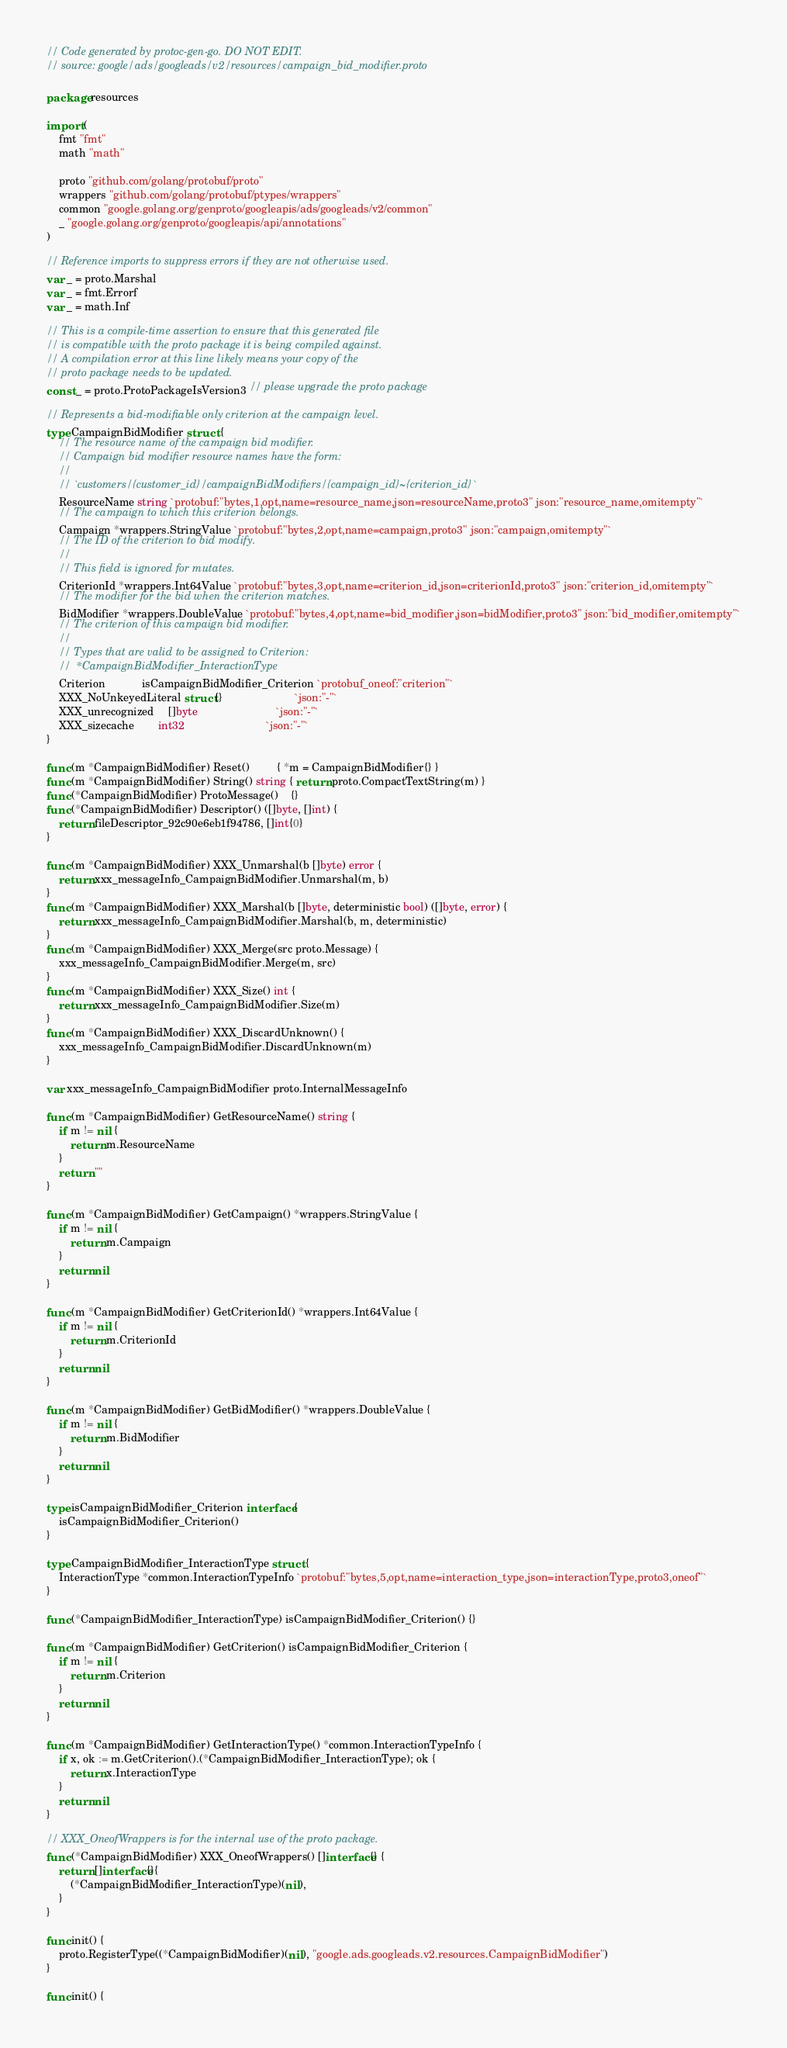<code> <loc_0><loc_0><loc_500><loc_500><_Go_>// Code generated by protoc-gen-go. DO NOT EDIT.
// source: google/ads/googleads/v2/resources/campaign_bid_modifier.proto

package resources

import (
	fmt "fmt"
	math "math"

	proto "github.com/golang/protobuf/proto"
	wrappers "github.com/golang/protobuf/ptypes/wrappers"
	common "google.golang.org/genproto/googleapis/ads/googleads/v2/common"
	_ "google.golang.org/genproto/googleapis/api/annotations"
)

// Reference imports to suppress errors if they are not otherwise used.
var _ = proto.Marshal
var _ = fmt.Errorf
var _ = math.Inf

// This is a compile-time assertion to ensure that this generated file
// is compatible with the proto package it is being compiled against.
// A compilation error at this line likely means your copy of the
// proto package needs to be updated.
const _ = proto.ProtoPackageIsVersion3 // please upgrade the proto package

// Represents a bid-modifiable only criterion at the campaign level.
type CampaignBidModifier struct {
	// The resource name of the campaign bid modifier.
	// Campaign bid modifier resource names have the form:
	//
	// `customers/{customer_id}/campaignBidModifiers/{campaign_id}~{criterion_id}`
	ResourceName string `protobuf:"bytes,1,opt,name=resource_name,json=resourceName,proto3" json:"resource_name,omitempty"`
	// The campaign to which this criterion belongs.
	Campaign *wrappers.StringValue `protobuf:"bytes,2,opt,name=campaign,proto3" json:"campaign,omitempty"`
	// The ID of the criterion to bid modify.
	//
	// This field is ignored for mutates.
	CriterionId *wrappers.Int64Value `protobuf:"bytes,3,opt,name=criterion_id,json=criterionId,proto3" json:"criterion_id,omitempty"`
	// The modifier for the bid when the criterion matches.
	BidModifier *wrappers.DoubleValue `protobuf:"bytes,4,opt,name=bid_modifier,json=bidModifier,proto3" json:"bid_modifier,omitempty"`
	// The criterion of this campaign bid modifier.
	//
	// Types that are valid to be assigned to Criterion:
	//	*CampaignBidModifier_InteractionType
	Criterion            isCampaignBidModifier_Criterion `protobuf_oneof:"criterion"`
	XXX_NoUnkeyedLiteral struct{}                        `json:"-"`
	XXX_unrecognized     []byte                          `json:"-"`
	XXX_sizecache        int32                           `json:"-"`
}

func (m *CampaignBidModifier) Reset()         { *m = CampaignBidModifier{} }
func (m *CampaignBidModifier) String() string { return proto.CompactTextString(m) }
func (*CampaignBidModifier) ProtoMessage()    {}
func (*CampaignBidModifier) Descriptor() ([]byte, []int) {
	return fileDescriptor_92c90e6eb1f94786, []int{0}
}

func (m *CampaignBidModifier) XXX_Unmarshal(b []byte) error {
	return xxx_messageInfo_CampaignBidModifier.Unmarshal(m, b)
}
func (m *CampaignBidModifier) XXX_Marshal(b []byte, deterministic bool) ([]byte, error) {
	return xxx_messageInfo_CampaignBidModifier.Marshal(b, m, deterministic)
}
func (m *CampaignBidModifier) XXX_Merge(src proto.Message) {
	xxx_messageInfo_CampaignBidModifier.Merge(m, src)
}
func (m *CampaignBidModifier) XXX_Size() int {
	return xxx_messageInfo_CampaignBidModifier.Size(m)
}
func (m *CampaignBidModifier) XXX_DiscardUnknown() {
	xxx_messageInfo_CampaignBidModifier.DiscardUnknown(m)
}

var xxx_messageInfo_CampaignBidModifier proto.InternalMessageInfo

func (m *CampaignBidModifier) GetResourceName() string {
	if m != nil {
		return m.ResourceName
	}
	return ""
}

func (m *CampaignBidModifier) GetCampaign() *wrappers.StringValue {
	if m != nil {
		return m.Campaign
	}
	return nil
}

func (m *CampaignBidModifier) GetCriterionId() *wrappers.Int64Value {
	if m != nil {
		return m.CriterionId
	}
	return nil
}

func (m *CampaignBidModifier) GetBidModifier() *wrappers.DoubleValue {
	if m != nil {
		return m.BidModifier
	}
	return nil
}

type isCampaignBidModifier_Criterion interface {
	isCampaignBidModifier_Criterion()
}

type CampaignBidModifier_InteractionType struct {
	InteractionType *common.InteractionTypeInfo `protobuf:"bytes,5,opt,name=interaction_type,json=interactionType,proto3,oneof"`
}

func (*CampaignBidModifier_InteractionType) isCampaignBidModifier_Criterion() {}

func (m *CampaignBidModifier) GetCriterion() isCampaignBidModifier_Criterion {
	if m != nil {
		return m.Criterion
	}
	return nil
}

func (m *CampaignBidModifier) GetInteractionType() *common.InteractionTypeInfo {
	if x, ok := m.GetCriterion().(*CampaignBidModifier_InteractionType); ok {
		return x.InteractionType
	}
	return nil
}

// XXX_OneofWrappers is for the internal use of the proto package.
func (*CampaignBidModifier) XXX_OneofWrappers() []interface{} {
	return []interface{}{
		(*CampaignBidModifier_InteractionType)(nil),
	}
}

func init() {
	proto.RegisterType((*CampaignBidModifier)(nil), "google.ads.googleads.v2.resources.CampaignBidModifier")
}

func init() {</code> 